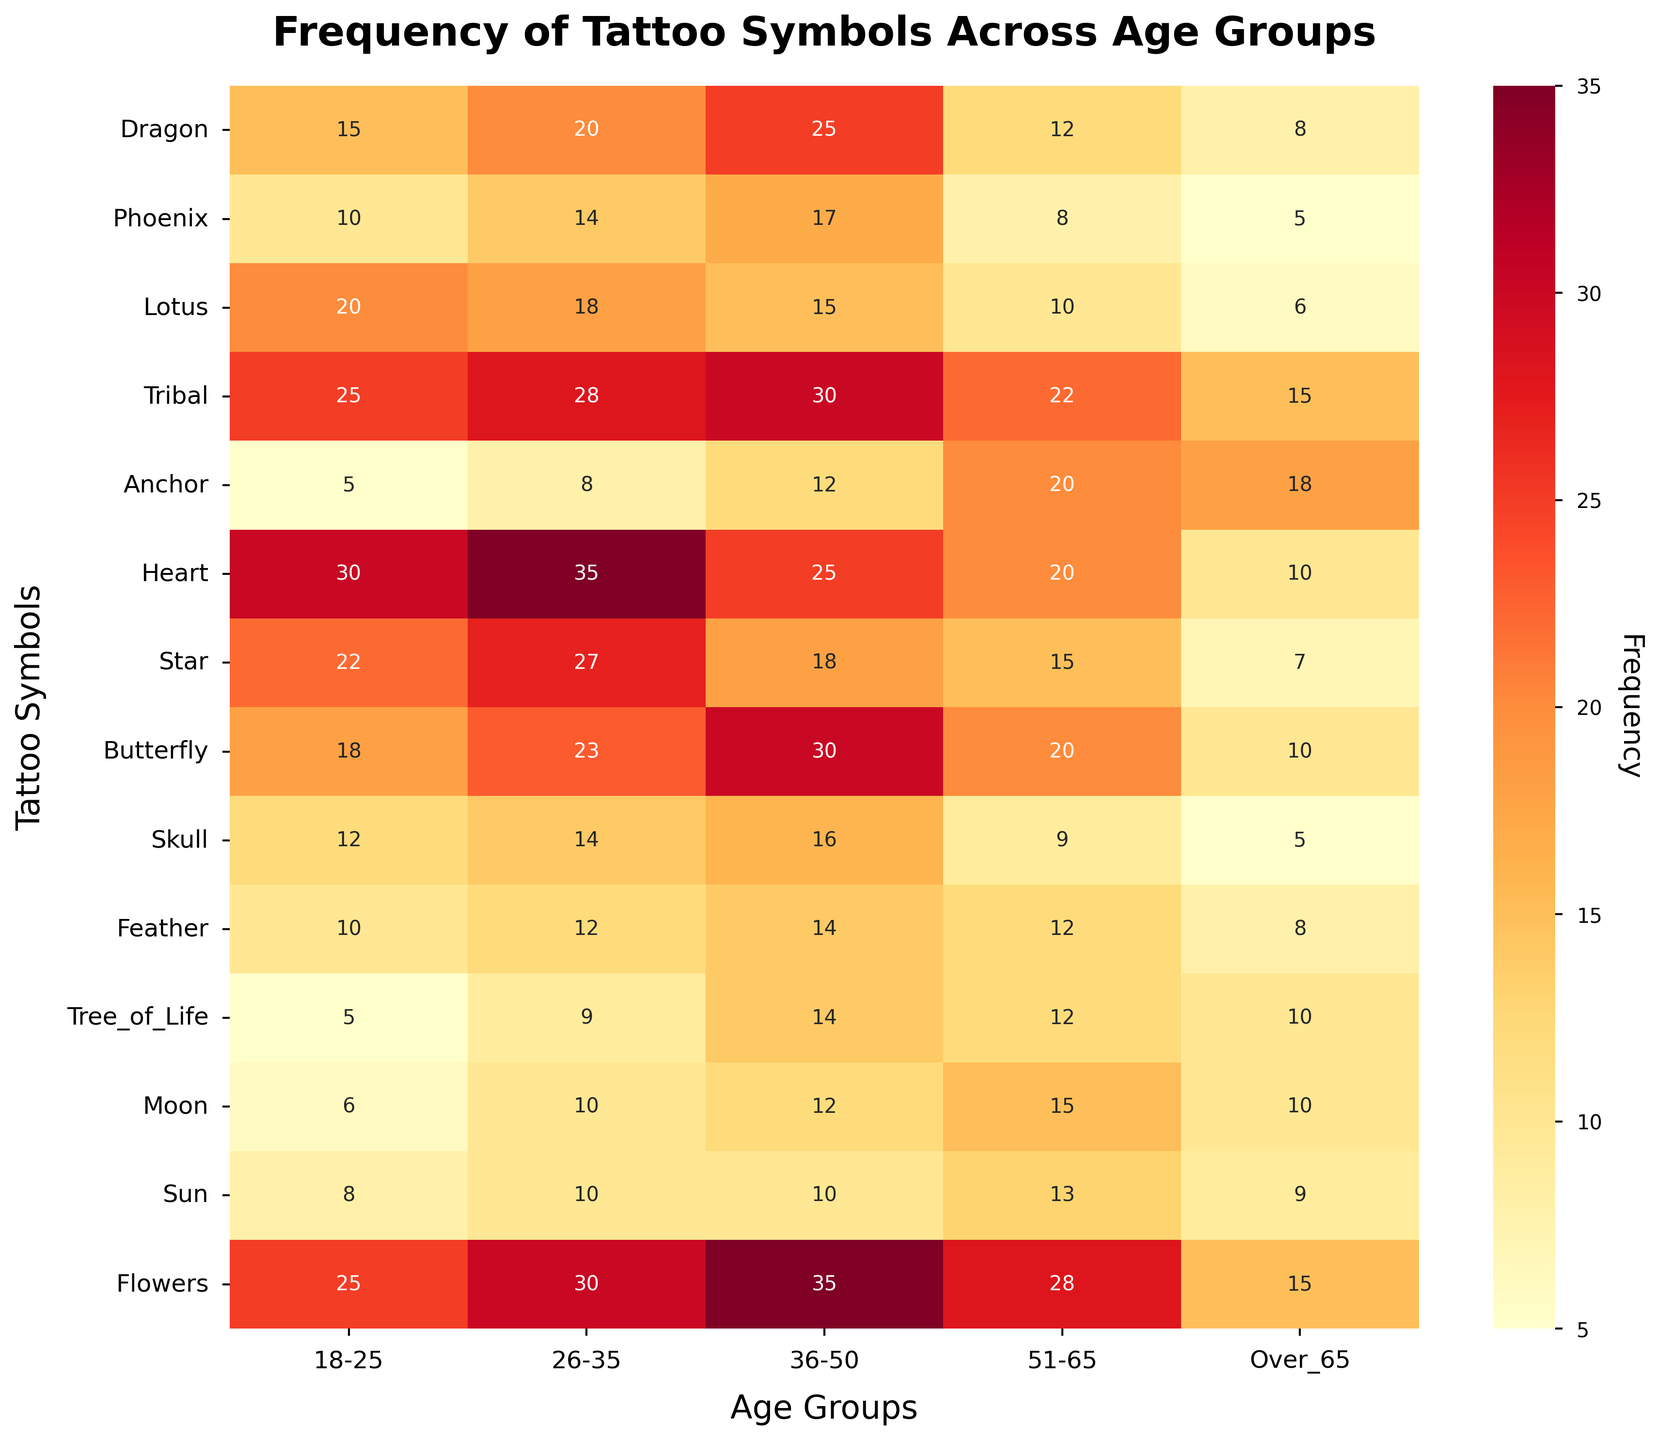What's the title of the heatmap? The title is typically placed at the top of the plot. In this case, it reads, "Frequency of Tattoo Symbols Across Age Groups."
Answer: Frequency of Tattoo Symbols Across Age Groups Which tattoo symbol is most popular among the 18-25 age group? To find the most popular symbol in the 18-25 age group, scan down the 18-25 column and identify the highest value.
Answer: Heart Which age group has the highest occurrence of the 'Anchor' tattoo? Look along the Anchor row and find the column with the highest value.
Answer: Over 65 What is the total number of 'Heart' tattoos across all age groups? Add the frequencies for the Heart tattoo across all age groups: 30+35+25+20+10.
Answer: 120 Which age group shows the least interest in 'Phoenix' tattoos? Find the smallest value in the Phoenix row by looking across all the columns.
Answer: Over 65 How does the popularity of 'Flowers' change with age? Observe the 'Flowers' row across age groups from left to right to see the trend: 25, 30, 35, 28, 15.
Answer: Starts high, peaks at 36-50, then declines Is the 'Star' symbol more popular among the 26-35 age group or the 51-65 age group? Compare the values in the Star row for the 26-35 and 51-65 columns.
Answer: 26-35 What's the average frequency of the 'Butterfly' tattoo across all age groups? Sum the frequencies for Butterfly and divide by the number of groups: (18+23+30+20+10)/5.
Answer: 20.2 Which tattoo symbols have the same frequency for the '36-50' age group? Look down the 36-50 column and find any identical values.
Answer: Sun and Skull How does the frequency of the 'Dragon' tattoo in the 36-50 age group compare to the 51-65 age group? Compare the specific values in the corresponding cells for 36-50 and 51-65 in the Dragon row.
Answer: More popular in 36-50 